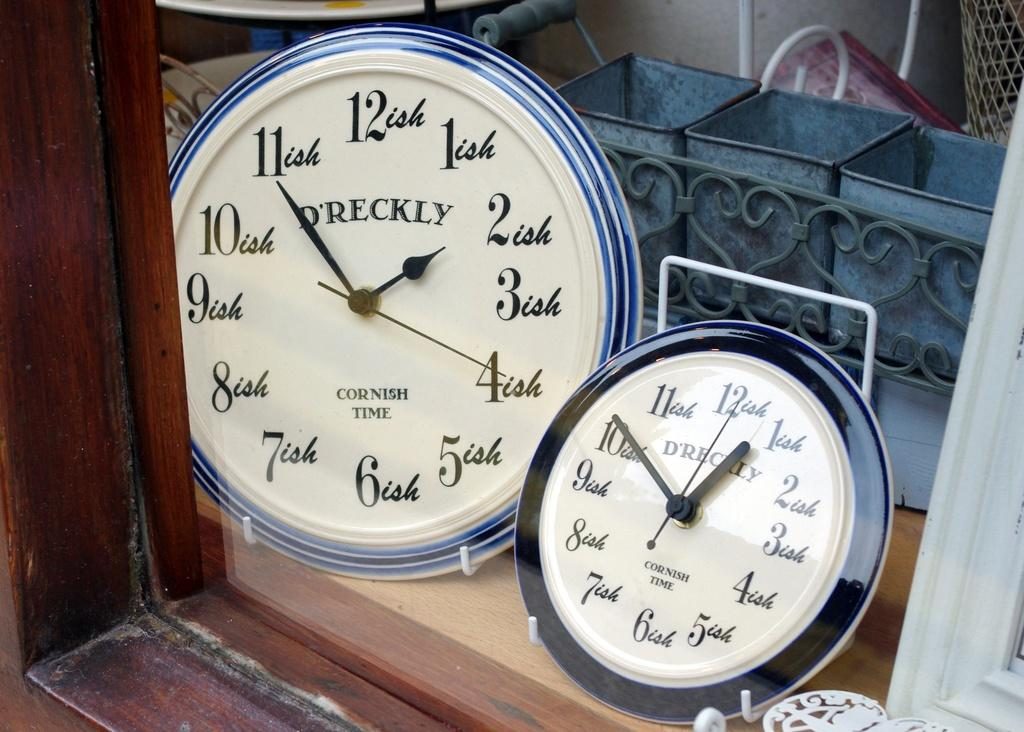<image>
Summarize the visual content of the image. Two D'Reckly Wall Clocks display Cornish Time in a shop window. 